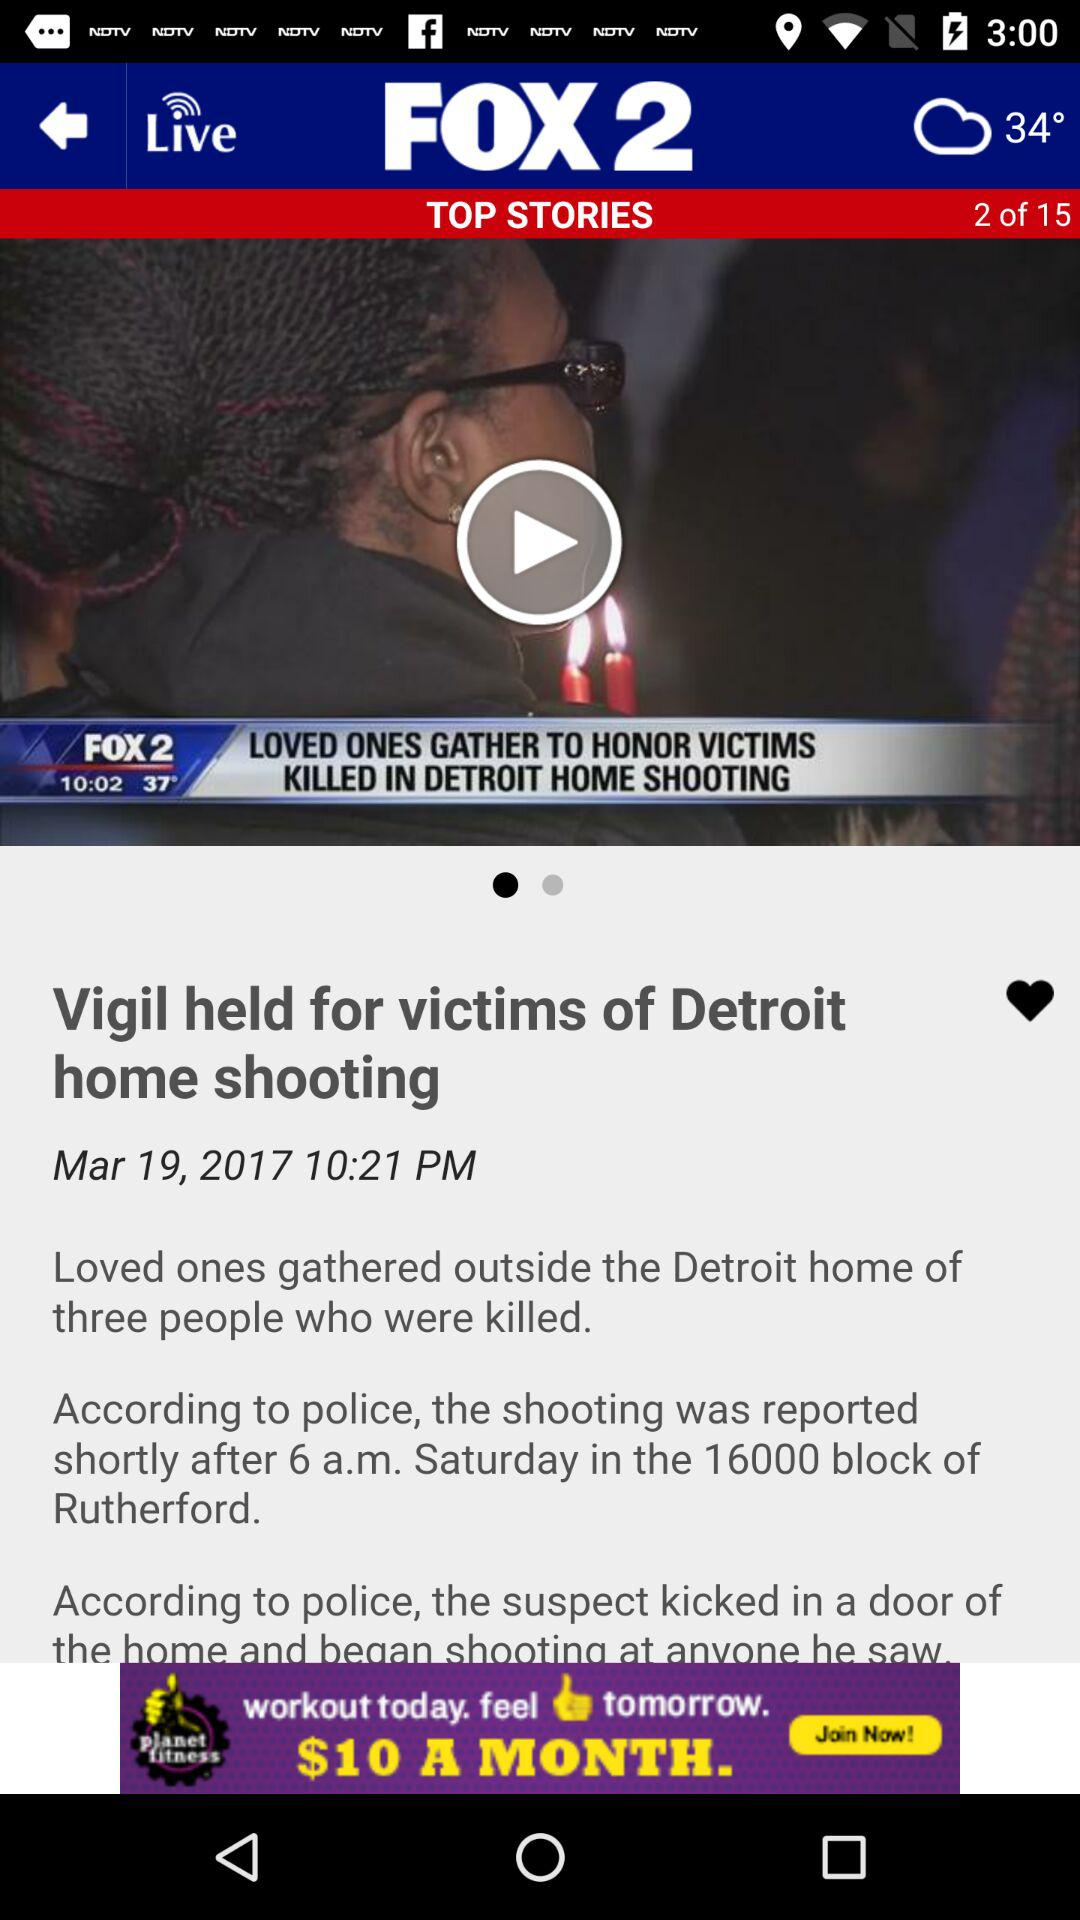What is the time at which the story is posted? The time is 10:21 PM. 